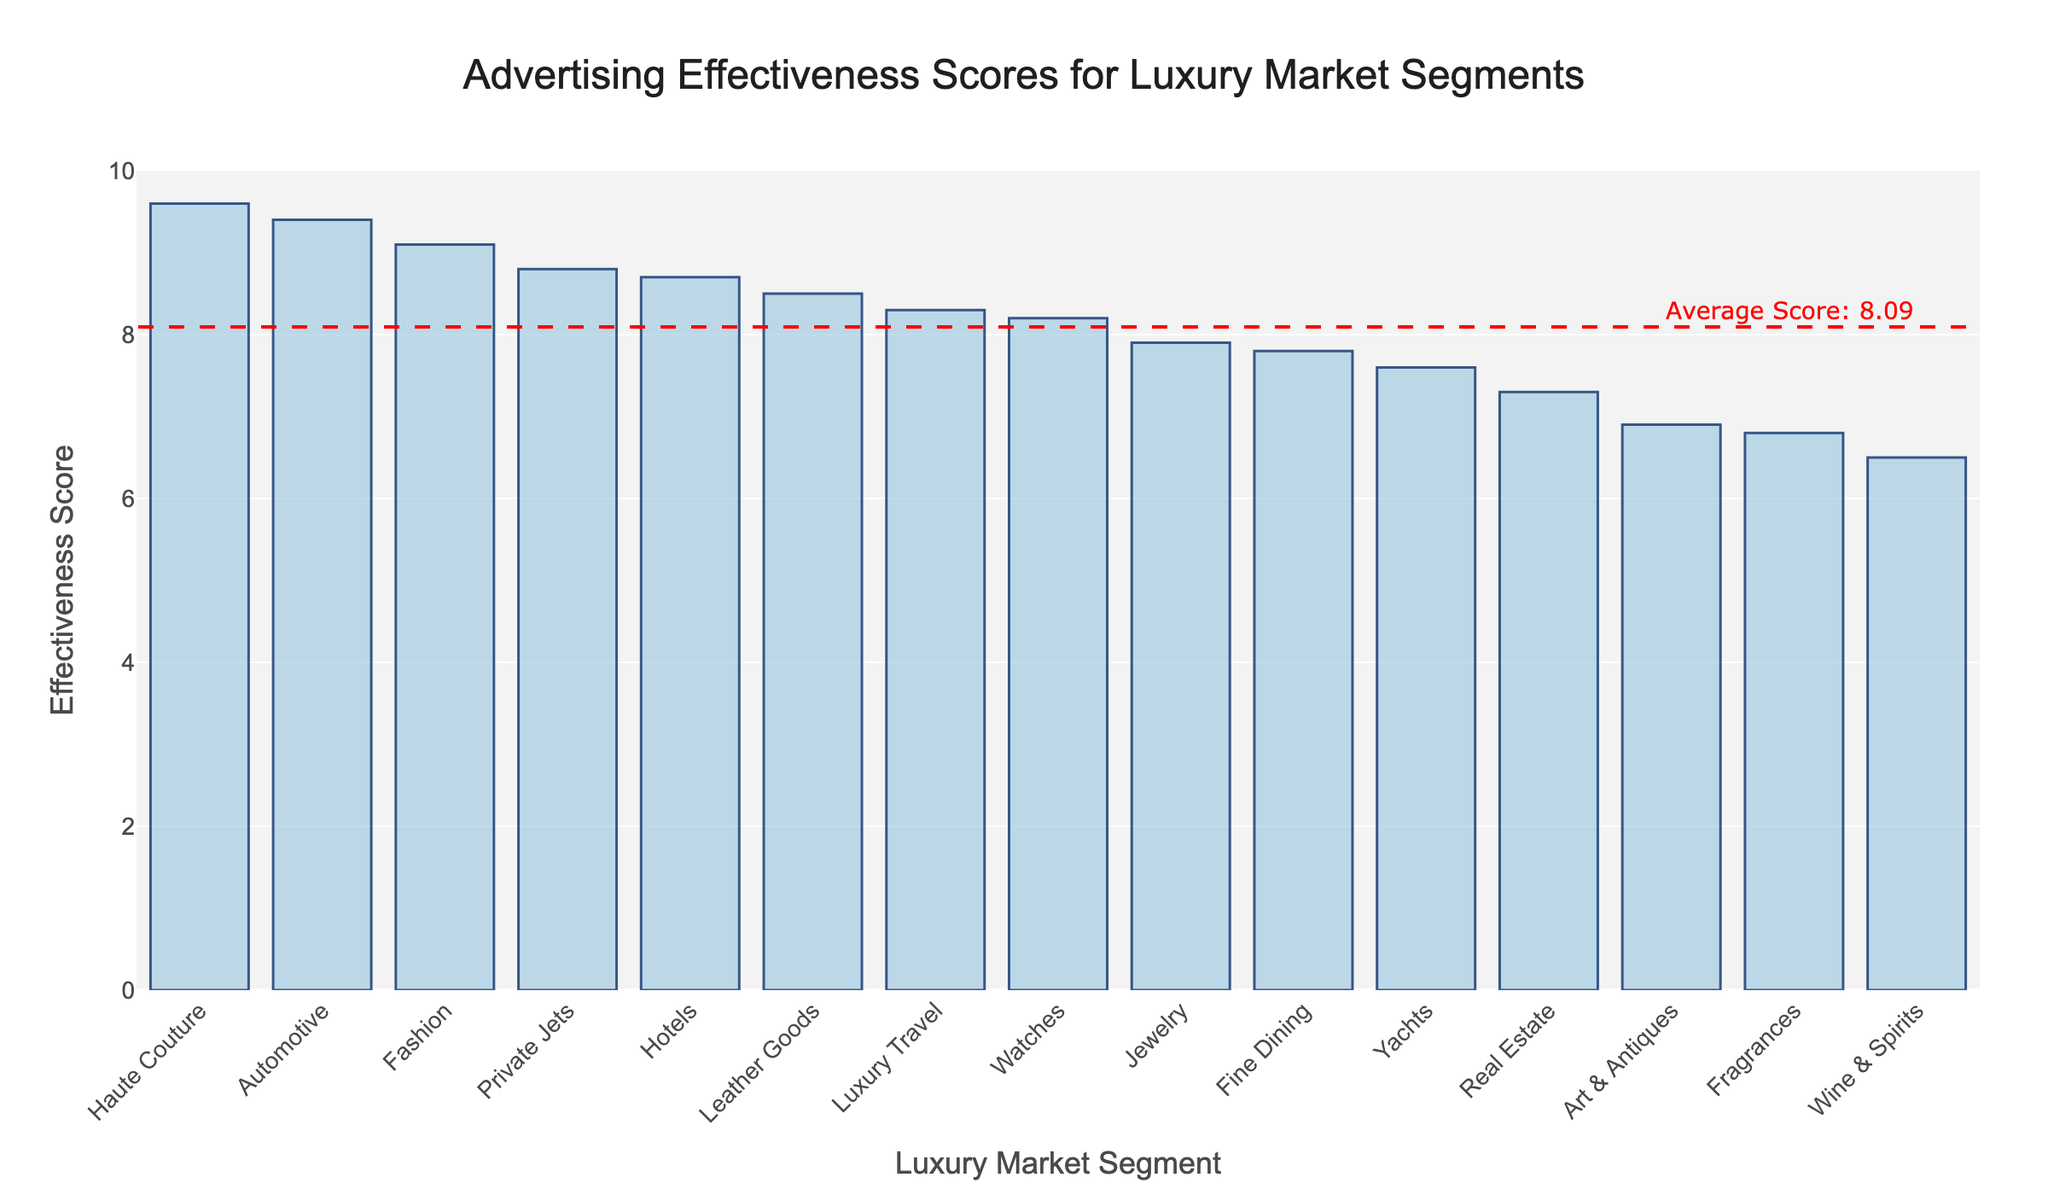what is the title of the plot? The title of the plot is prominently displayed at the top of the figure, centered and reads "Advertising Effectiveness Scores for Luxury Market Segments."
Answer: Advertising Effectiveness Scores for Luxury Market Segments How many luxury market segments are represented in the plot? Each vertical bar represents a different luxury market segment, and by counting them, we see there are 15 segments.
Answer: 15 Which luxury market segment has the highest effectiveness score? By examining the height of the bars, the tallest one represents "Haute Couture," with a score of 9.6, making it the highest.
Answer: Haute Couture What is the lowest effectiveness score, and which segment does it correspond to? The shortest bar represents the "Wine & Spirits" segment with the lowest score of 6.5.
Answer: Wine & Spirits, 6.5 Compare the effectiveness scores of "Fashion" and "Automotive." Which segment has a higher score? The bar for "Automotive" is taller than the one for "Fashion"; "Automotive" has a score of 9.4, and "Fashion" has 9.1 leading to the conclusion that "Automotive" has a higher score.
Answer: Automotive Is the average effectiveness score higher or lower than 8? The plot includes a dashed red line and an annotation indicating the average score, which is lower than 8, as shown visually on the y-axis.
Answer: Lower What is the difference between the highest and the lowest effectiveness score? The highest score is 9.6 (Haute Couture) and the lowest is 6.5 (Wine & Spirits). The difference is calculated as 9.6 - 6.5 = 3.1.
Answer: 3.1 Which category comes closest to the average score? The plot shows the average score as a dashed red line. "Luxury Travel" is closest with its bar very near to this line and annotated as the "Average Score: 7.91."
Answer: Luxury Travel What is the combined effectiveness score for "Private Jets" and "Hotels"? The effectiveness score for "Private Jets" is 8.8, and for "Hotels," it's 8.7. Adding these, 8.8 + 8.7 = 17.5.
Answer: 17.5 Which two segments have scores closest to each other? By visually inspecting the bars, "Jewelry" and "Fine Dining" have scores very close; "Jewelry" has 7.9 and "Fine Dining" has 7.8, so they are closest in score.
Answer: Jewelry and Fine Dining 